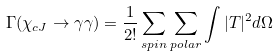Convert formula to latex. <formula><loc_0><loc_0><loc_500><loc_500>\Gamma ( \chi _ { c J } \rightarrow \gamma \gamma ) = \frac { 1 } { 2 ! } \sum _ { s p i n } \sum _ { p o l a r } \int | T | ^ { 2 } d \Omega</formula> 